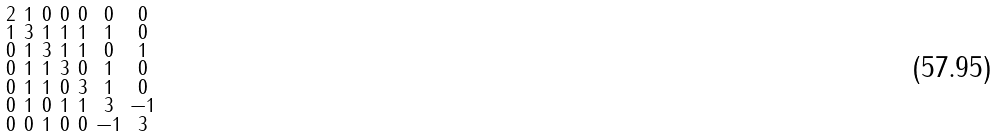<formula> <loc_0><loc_0><loc_500><loc_500>\begin{smallmatrix} 2 & 1 & 0 & 0 & 0 & 0 & 0 \\ 1 & 3 & 1 & 1 & 1 & 1 & 0 \\ 0 & 1 & 3 & 1 & 1 & 0 & 1 \\ 0 & 1 & 1 & 3 & 0 & 1 & 0 \\ 0 & 1 & 1 & 0 & 3 & 1 & 0 \\ 0 & 1 & 0 & 1 & 1 & 3 & - 1 \\ 0 & 0 & 1 & 0 & 0 & - 1 & 3 \end{smallmatrix}</formula> 